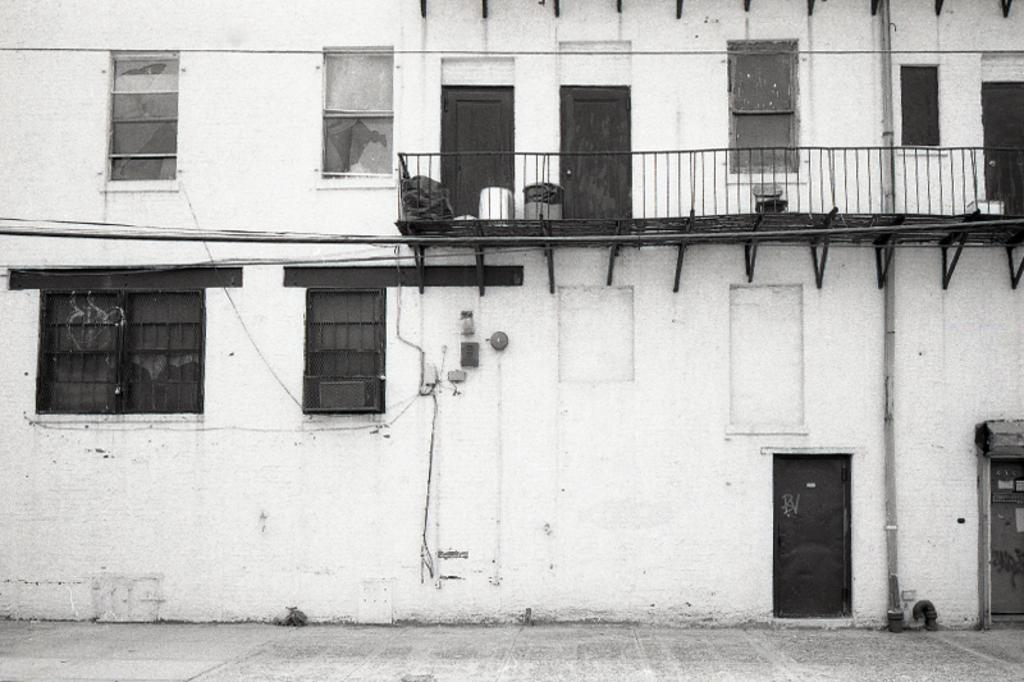What is the color scheme of the image? The image is black and white. What structure can be seen in the image? There is a building in the image. What features are present on the building? The building has windows and a door. What additional elements can be found in the image? There is a railing and a pipe in the image. How many pigs are visible in the image? There are no pigs present in the image. What type of deer can be seen near the building in the image? There are no deer present in the image. 